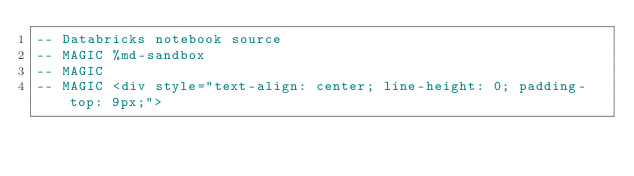<code> <loc_0><loc_0><loc_500><loc_500><_SQL_>-- Databricks notebook source
-- MAGIC %md-sandbox
-- MAGIC 
-- MAGIC <div style="text-align: center; line-height: 0; padding-top: 9px;"></code> 